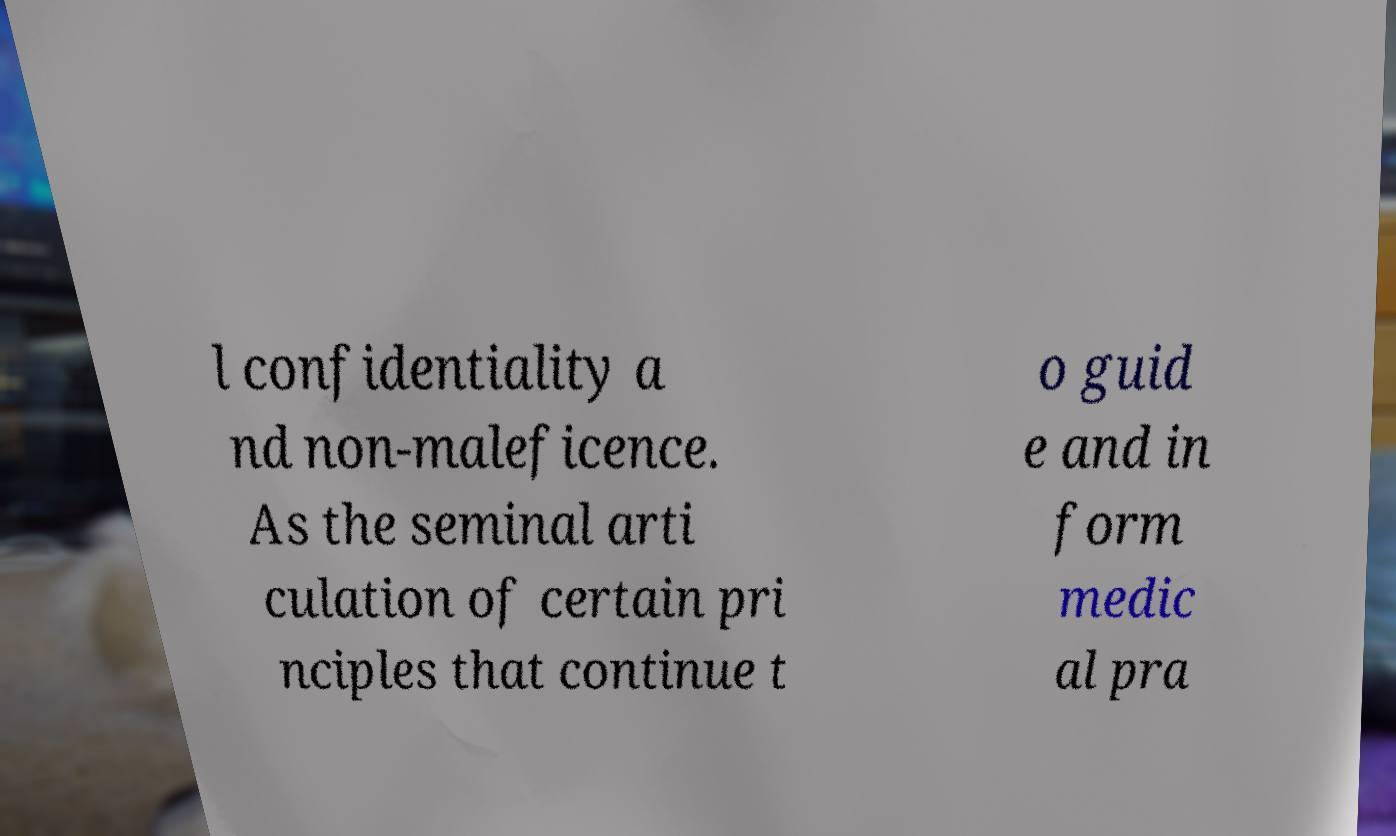For documentation purposes, I need the text within this image transcribed. Could you provide that? l confidentiality a nd non-maleficence. As the seminal arti culation of certain pri nciples that continue t o guid e and in form medic al pra 